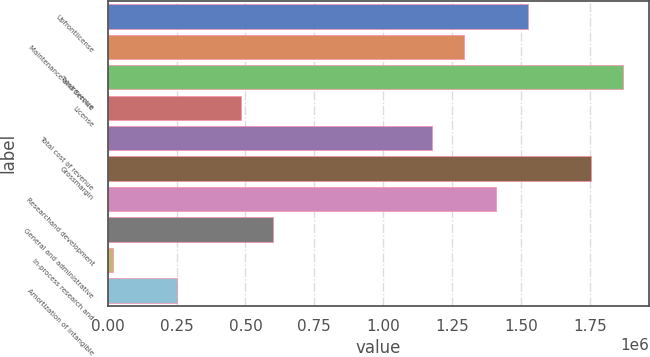Convert chart. <chart><loc_0><loc_0><loc_500><loc_500><bar_chart><fcel>Upfrontlicense<fcel>Maintenance and Service<fcel>Totalrevenue<fcel>License<fcel>Total cost of revenue<fcel>Grossmargin<fcel>Researchand development<fcel>General and administrative<fcel>In-process research and<fcel>Amortization of intangible<nl><fcel>1.52412e+06<fcel>1.2927e+06<fcel>1.87126e+06<fcel>482703<fcel>1.17698e+06<fcel>1.75555e+06<fcel>1.40841e+06<fcel>598416<fcel>19850<fcel>251277<nl></chart> 